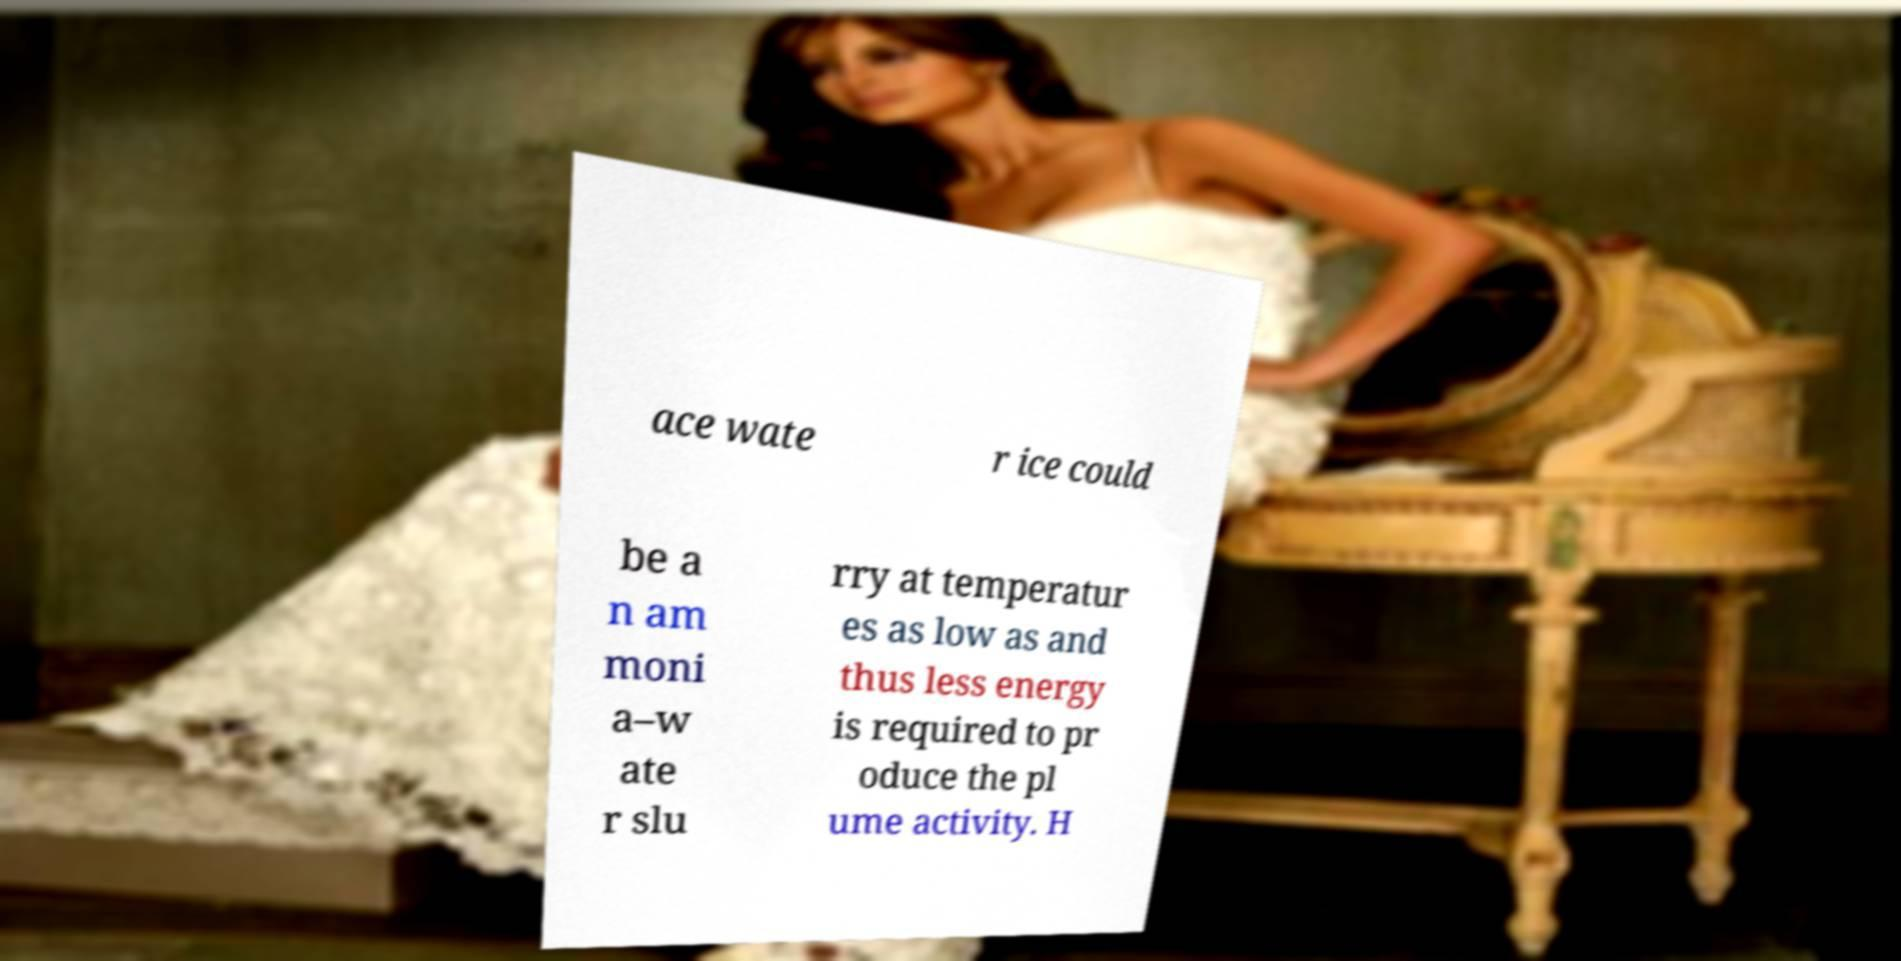Can you accurately transcribe the text from the provided image for me? ace wate r ice could be a n am moni a–w ate r slu rry at temperatur es as low as and thus less energy is required to pr oduce the pl ume activity. H 